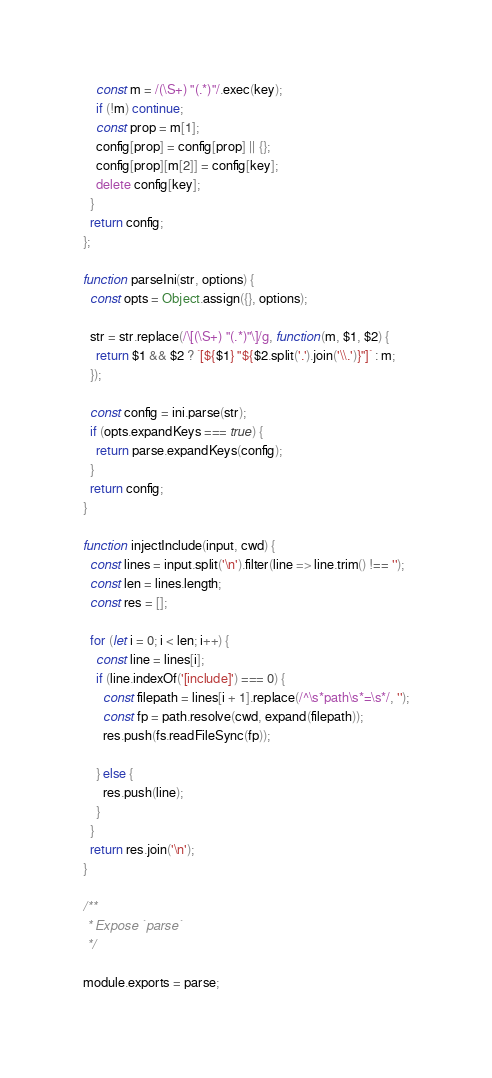<code> <loc_0><loc_0><loc_500><loc_500><_JavaScript_>    const m = /(\S+) "(.*)"/.exec(key);
    if (!m) continue;
    const prop = m[1];
    config[prop] = config[prop] || {};
    config[prop][m[2]] = config[key];
    delete config[key];
  }
  return config;
};

function parseIni(str, options) {
  const opts = Object.assign({}, options);

  str = str.replace(/\[(\S+) "(.*)"\]/g, function(m, $1, $2) {
    return $1 && $2 ? `[${$1} "${$2.split('.').join('\\.')}"]` : m;
  });

  const config = ini.parse(str);
  if (opts.expandKeys === true) {
    return parse.expandKeys(config);
  }
  return config;
}

function injectInclude(input, cwd) {
  const lines = input.split('\n').filter(line => line.trim() !== '');
  const len = lines.length;
  const res = [];

  for (let i = 0; i < len; i++) {
    const line = lines[i];
    if (line.indexOf('[include]') === 0) {
      const filepath = lines[i + 1].replace(/^\s*path\s*=\s*/, '');
      const fp = path.resolve(cwd, expand(filepath));
      res.push(fs.readFileSync(fp));

    } else {
      res.push(line);
    }
  }
  return res.join('\n');
}

/**
 * Expose `parse`
 */

module.exports = parse;
</code> 